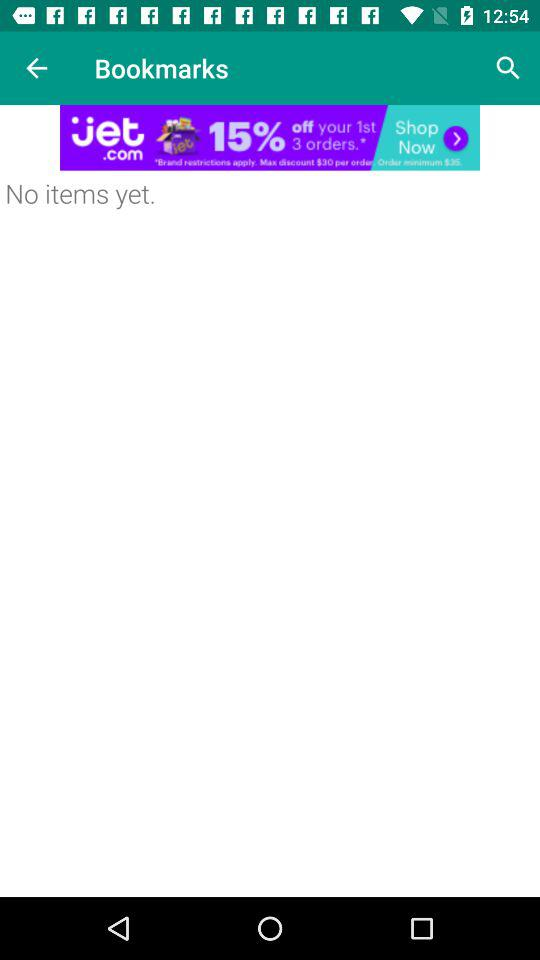What is the name of the application?
When the provided information is insufficient, respond with <no answer>. <no answer> 